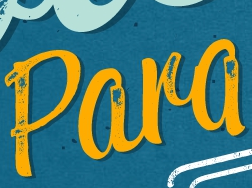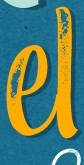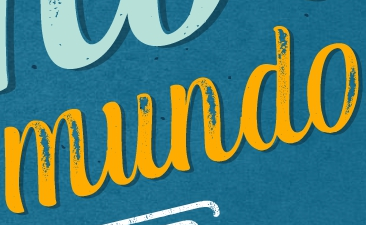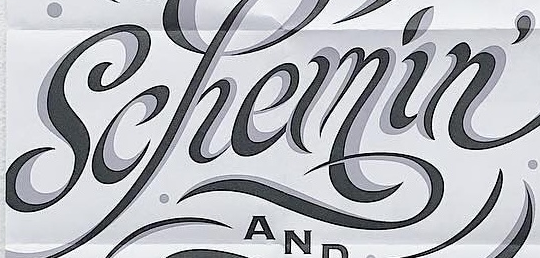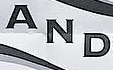Read the text from these images in sequence, separated by a semicolon. Para; el; mundo; Schemin'; AND 